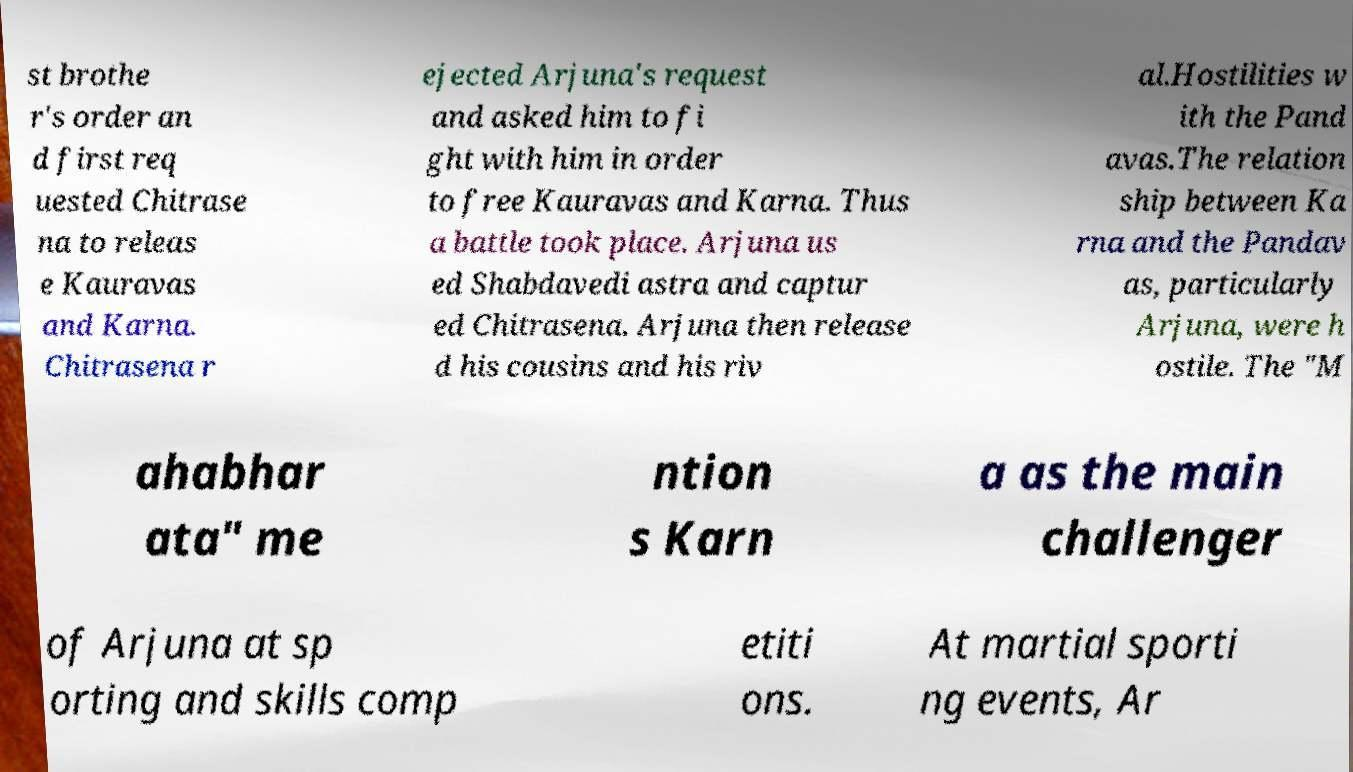Can you read and provide the text displayed in the image?This photo seems to have some interesting text. Can you extract and type it out for me? st brothe r's order an d first req uested Chitrase na to releas e Kauravas and Karna. Chitrasena r ejected Arjuna's request and asked him to fi ght with him in order to free Kauravas and Karna. Thus a battle took place. Arjuna us ed Shabdavedi astra and captur ed Chitrasena. Arjuna then release d his cousins and his riv al.Hostilities w ith the Pand avas.The relation ship between Ka rna and the Pandav as, particularly Arjuna, were h ostile. The "M ahabhar ata" me ntion s Karn a as the main challenger of Arjuna at sp orting and skills comp etiti ons. At martial sporti ng events, Ar 